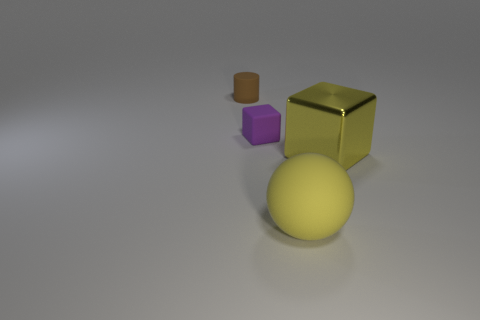Add 3 brown cylinders. How many objects exist? 7 Subtract all cylinders. How many objects are left? 3 Subtract 1 purple blocks. How many objects are left? 3 Subtract all tiny brown rubber objects. Subtract all cylinders. How many objects are left? 2 Add 2 tiny brown cylinders. How many tiny brown cylinders are left? 3 Add 4 large purple rubber balls. How many large purple rubber balls exist? 4 